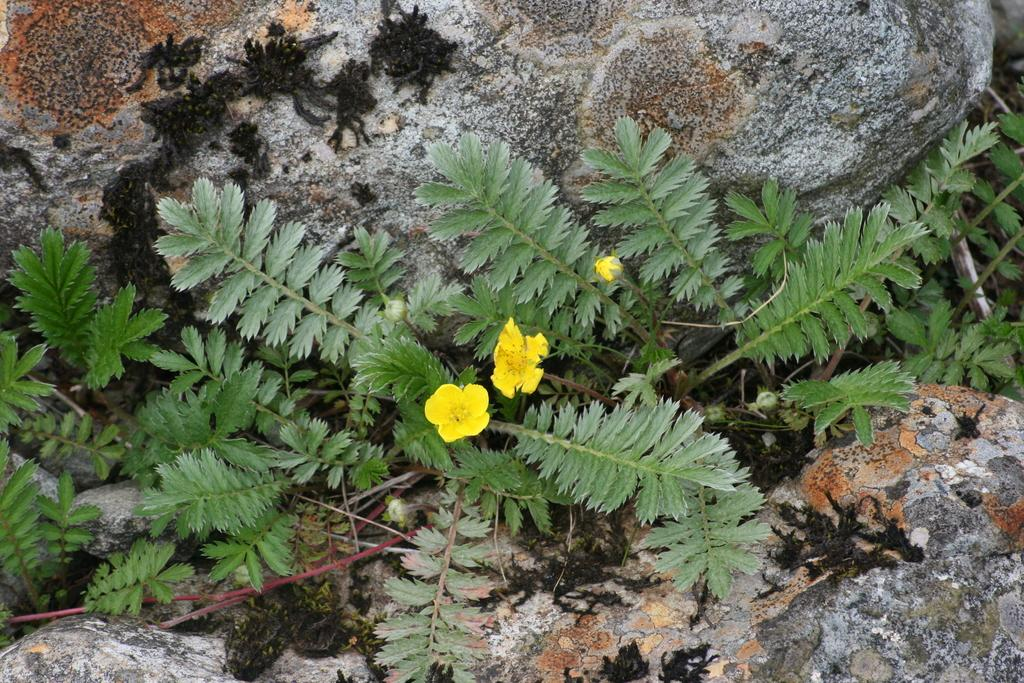What type of plant is visible in the image? There is a flower plant in the image. How is the flower plant positioned in relation to other objects? The flower plant is situated between stones. How many pizzas are stacked on top of the flower plant in the image? There are no pizzas present in the image; it features a flower plant situated between stones. 